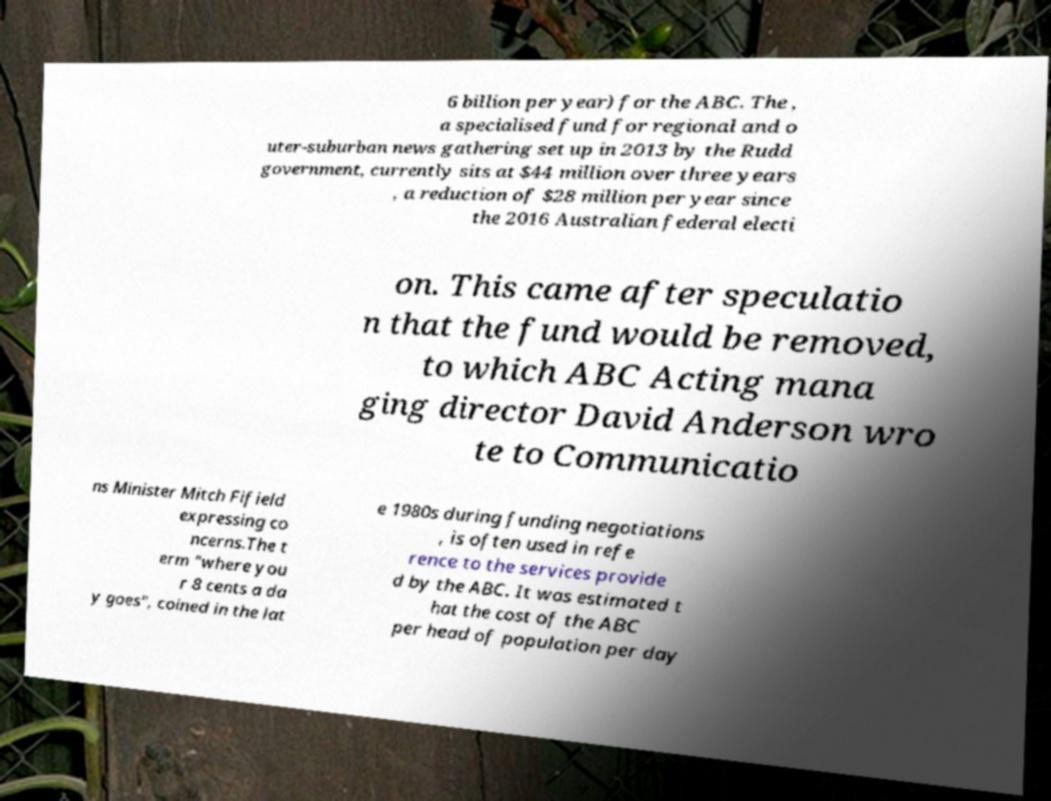For documentation purposes, I need the text within this image transcribed. Could you provide that? 6 billion per year) for the ABC. The , a specialised fund for regional and o uter-suburban news gathering set up in 2013 by the Rudd government, currently sits at $44 million over three years , a reduction of $28 million per year since the 2016 Australian federal electi on. This came after speculatio n that the fund would be removed, to which ABC Acting mana ging director David Anderson wro te to Communicatio ns Minister Mitch Fifield expressing co ncerns.The t erm "where you r 8 cents a da y goes", coined in the lat e 1980s during funding negotiations , is often used in refe rence to the services provide d by the ABC. It was estimated t hat the cost of the ABC per head of population per day 